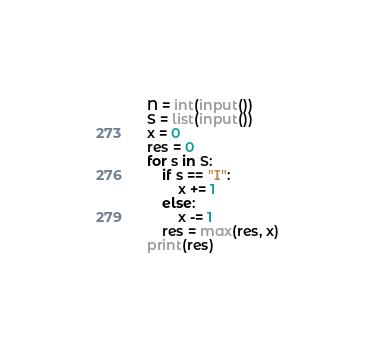Convert code to text. <code><loc_0><loc_0><loc_500><loc_500><_Python_>N = int(input())
S = list(input())
x = 0
res = 0
for s in S:
    if s == "I":
        x += 1
    else:
        x -= 1
    res = max(res, x)
print(res)
</code> 